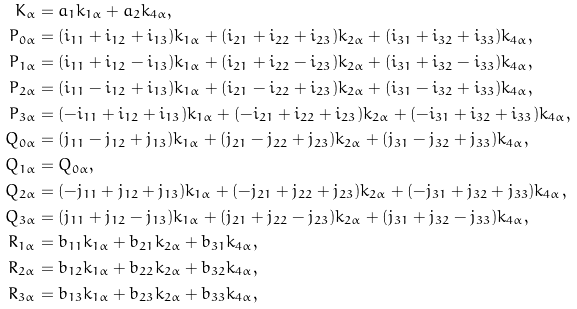<formula> <loc_0><loc_0><loc_500><loc_500>K _ { \alpha } & = a _ { 1 } k _ { 1 \alpha } + a _ { 2 } k _ { 4 \alpha } , \\ P _ { 0 \alpha } & = ( i _ { 1 1 } + i _ { 1 2 } + i _ { 1 3 } ) k _ { 1 \alpha } + ( i _ { 2 1 } + i _ { 2 2 } + i _ { 2 3 } ) k _ { 2 \alpha } + ( i _ { 3 1 } + i _ { 3 2 } + i _ { 3 3 } ) k _ { 4 \alpha } , \\ P _ { 1 \alpha } & = ( i _ { 1 1 } + i _ { 1 2 } - i _ { 1 3 } ) k _ { 1 \alpha } + ( i _ { 2 1 } + i _ { 2 2 } - i _ { 2 3 } ) k _ { 2 \alpha } + ( i _ { 3 1 } + i _ { 3 2 } - i _ { 3 3 } ) k _ { 4 \alpha } , \\ P _ { 2 \alpha } & = ( i _ { 1 1 } - i _ { 1 2 } + i _ { 1 3 } ) k _ { 1 \alpha } + ( i _ { 2 1 } - i _ { 2 2 } + i _ { 2 3 } ) k _ { 2 \alpha } + ( i _ { 3 1 } - i _ { 3 2 } + i _ { 3 3 } ) k _ { 4 \alpha } , \\ P _ { 3 \alpha } & = ( - i _ { 1 1 } + i _ { 1 2 } + i _ { 1 3 } ) k _ { 1 \alpha } + ( - i _ { 2 1 } + i _ { 2 2 } + i _ { 2 3 } ) k _ { 2 \alpha } + ( - i _ { 3 1 } + i _ { 3 2 } + i _ { 3 3 } ) k _ { 4 \alpha } , \\ Q _ { 0 \alpha } & = ( j _ { 1 1 } - j _ { 1 2 } + j _ { 1 3 } ) k _ { 1 \alpha } + ( j _ { 2 1 } - j _ { 2 2 } + j _ { 2 3 } ) k _ { 2 \alpha } + ( j _ { 3 1 } - j _ { 3 2 } + j _ { 3 3 } ) k _ { 4 \alpha } , \\ Q _ { 1 \alpha } & = Q _ { 0 \alpha } , \\ Q _ { 2 \alpha } & = ( - j _ { 1 1 } + j _ { 1 2 } + j _ { 1 3 } ) k _ { 1 \alpha } + ( - j _ { 2 1 } + j _ { 2 2 } + j _ { 2 3 } ) k _ { 2 \alpha } + ( - j _ { 3 1 } + j _ { 3 2 } + j _ { 3 3 } ) k _ { 4 \alpha } , \\ Q _ { 3 \alpha } & = ( j _ { 1 1 } + j _ { 1 2 } - j _ { 1 3 } ) k _ { 1 \alpha } + ( j _ { 2 1 } + j _ { 2 2 } - j _ { 2 3 } ) k _ { 2 \alpha } + ( j _ { 3 1 } + j _ { 3 2 } - j _ { 3 3 } ) k _ { 4 \alpha } , \\ R _ { 1 \alpha } & = b _ { 1 1 } k _ { 1 \alpha } + b _ { 2 1 } k _ { 2 \alpha } + b _ { 3 1 } k _ { 4 \alpha } , \\ R _ { 2 \alpha } & = b _ { 1 2 } k _ { 1 \alpha } + b _ { 2 2 } k _ { 2 \alpha } + b _ { 3 2 } k _ { 4 \alpha } , \\ R _ { 3 \alpha } & = b _ { 1 3 } k _ { 1 \alpha } + b _ { 2 3 } k _ { 2 \alpha } + b _ { 3 3 } k _ { 4 \alpha } ,</formula> 